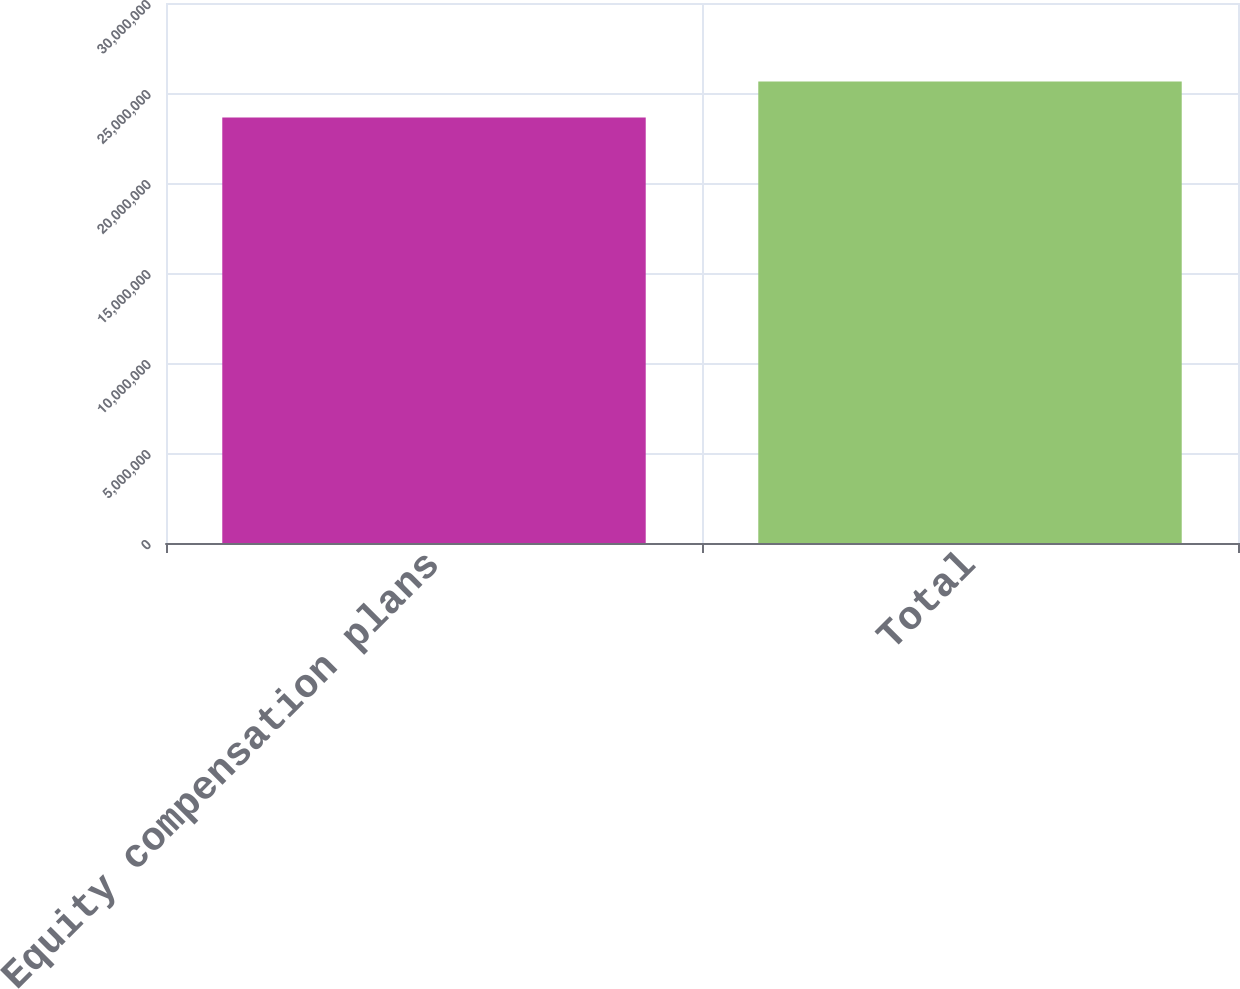Convert chart. <chart><loc_0><loc_0><loc_500><loc_500><bar_chart><fcel>Equity compensation plans<fcel>Total<nl><fcel>2.36336e+07<fcel>2.56336e+07<nl></chart> 